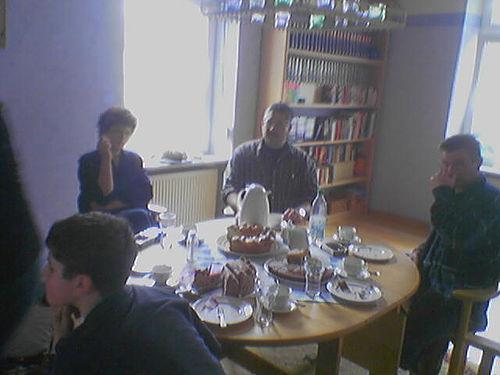How many dining tables are in the picture?
Give a very brief answer. 1. How many people are there?
Give a very brief answer. 4. How many books can be seen?
Give a very brief answer. 2. 